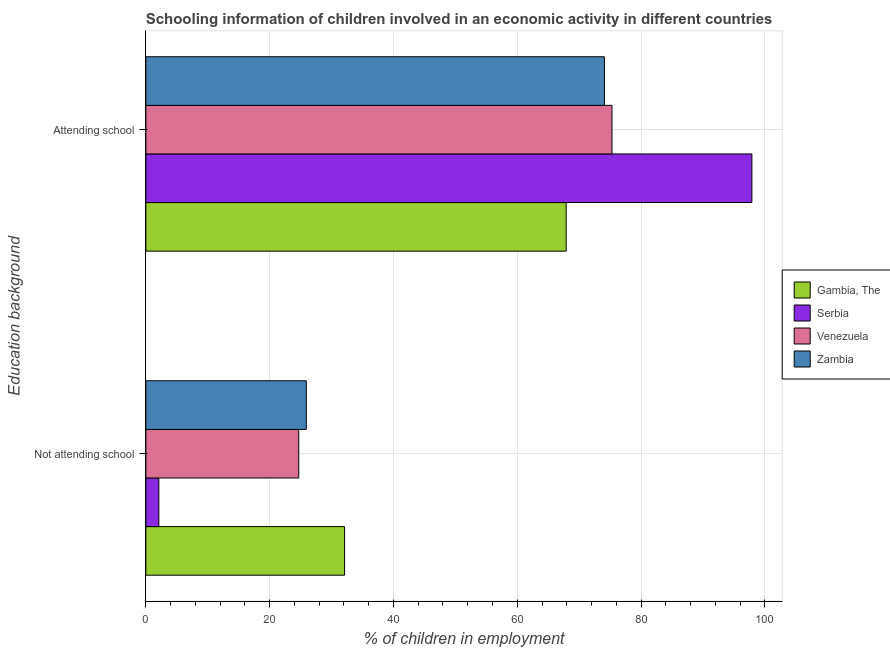How many groups of bars are there?
Keep it short and to the point. 2. How many bars are there on the 2nd tick from the top?
Give a very brief answer. 4. How many bars are there on the 2nd tick from the bottom?
Keep it short and to the point. 4. What is the label of the 1st group of bars from the top?
Your answer should be compact. Attending school. What is the percentage of employed children who are not attending school in Venezuela?
Offer a very short reply. 24.7. Across all countries, what is the maximum percentage of employed children who are not attending school?
Offer a very short reply. 32.1. Across all countries, what is the minimum percentage of employed children who are not attending school?
Provide a short and direct response. 2.1. In which country was the percentage of employed children who are not attending school maximum?
Your answer should be very brief. Gambia, The. In which country was the percentage of employed children who are attending school minimum?
Your response must be concise. Gambia, The. What is the total percentage of employed children who are attending school in the graph?
Offer a terse response. 315.18. What is the difference between the percentage of employed children who are not attending school in Gambia, The and that in Zambia?
Your response must be concise. 6.18. What is the difference between the percentage of employed children who are attending school in Zambia and the percentage of employed children who are not attending school in Gambia, The?
Offer a terse response. 41.98. What is the average percentage of employed children who are attending school per country?
Make the answer very short. 78.79. What is the difference between the percentage of employed children who are attending school and percentage of employed children who are not attending school in Gambia, The?
Ensure brevity in your answer.  35.8. In how many countries, is the percentage of employed children who are attending school greater than 56 %?
Keep it short and to the point. 4. What is the ratio of the percentage of employed children who are attending school in Serbia to that in Zambia?
Make the answer very short. 1.32. Is the percentage of employed children who are not attending school in Venezuela less than that in Serbia?
Provide a succinct answer. No. What does the 1st bar from the top in Not attending school represents?
Your response must be concise. Zambia. What does the 1st bar from the bottom in Attending school represents?
Your response must be concise. Gambia, The. How many bars are there?
Provide a short and direct response. 8. Are all the bars in the graph horizontal?
Your answer should be compact. Yes. What is the difference between two consecutive major ticks on the X-axis?
Offer a very short reply. 20. Are the values on the major ticks of X-axis written in scientific E-notation?
Provide a short and direct response. No. How are the legend labels stacked?
Offer a terse response. Vertical. What is the title of the graph?
Provide a short and direct response. Schooling information of children involved in an economic activity in different countries. What is the label or title of the X-axis?
Keep it short and to the point. % of children in employment. What is the label or title of the Y-axis?
Give a very brief answer. Education background. What is the % of children in employment in Gambia, The in Not attending school?
Offer a terse response. 32.1. What is the % of children in employment of Venezuela in Not attending school?
Your answer should be very brief. 24.7. What is the % of children in employment of Zambia in Not attending school?
Your answer should be very brief. 25.92. What is the % of children in employment of Gambia, The in Attending school?
Make the answer very short. 67.9. What is the % of children in employment in Serbia in Attending school?
Make the answer very short. 97.9. What is the % of children in employment of Venezuela in Attending school?
Make the answer very short. 75.3. What is the % of children in employment in Zambia in Attending school?
Make the answer very short. 74.08. Across all Education background, what is the maximum % of children in employment of Gambia, The?
Keep it short and to the point. 67.9. Across all Education background, what is the maximum % of children in employment in Serbia?
Provide a short and direct response. 97.9. Across all Education background, what is the maximum % of children in employment of Venezuela?
Provide a short and direct response. 75.3. Across all Education background, what is the maximum % of children in employment in Zambia?
Offer a very short reply. 74.08. Across all Education background, what is the minimum % of children in employment in Gambia, The?
Offer a very short reply. 32.1. Across all Education background, what is the minimum % of children in employment in Serbia?
Keep it short and to the point. 2.1. Across all Education background, what is the minimum % of children in employment in Venezuela?
Your response must be concise. 24.7. Across all Education background, what is the minimum % of children in employment in Zambia?
Provide a succinct answer. 25.92. What is the total % of children in employment in Serbia in the graph?
Provide a succinct answer. 100. What is the total % of children in employment in Venezuela in the graph?
Give a very brief answer. 100. What is the difference between the % of children in employment of Gambia, The in Not attending school and that in Attending school?
Make the answer very short. -35.8. What is the difference between the % of children in employment of Serbia in Not attending school and that in Attending school?
Your response must be concise. -95.8. What is the difference between the % of children in employment of Venezuela in Not attending school and that in Attending school?
Keep it short and to the point. -50.6. What is the difference between the % of children in employment of Zambia in Not attending school and that in Attending school?
Offer a terse response. -48.15. What is the difference between the % of children in employment of Gambia, The in Not attending school and the % of children in employment of Serbia in Attending school?
Provide a short and direct response. -65.8. What is the difference between the % of children in employment in Gambia, The in Not attending school and the % of children in employment in Venezuela in Attending school?
Offer a terse response. -43.2. What is the difference between the % of children in employment of Gambia, The in Not attending school and the % of children in employment of Zambia in Attending school?
Offer a very short reply. -41.98. What is the difference between the % of children in employment of Serbia in Not attending school and the % of children in employment of Venezuela in Attending school?
Provide a short and direct response. -73.2. What is the difference between the % of children in employment of Serbia in Not attending school and the % of children in employment of Zambia in Attending school?
Your answer should be very brief. -71.98. What is the difference between the % of children in employment of Venezuela in Not attending school and the % of children in employment of Zambia in Attending school?
Offer a terse response. -49.38. What is the average % of children in employment in Serbia per Education background?
Give a very brief answer. 50. What is the average % of children in employment in Venezuela per Education background?
Offer a very short reply. 50. What is the difference between the % of children in employment in Gambia, The and % of children in employment in Zambia in Not attending school?
Give a very brief answer. 6.18. What is the difference between the % of children in employment in Serbia and % of children in employment in Venezuela in Not attending school?
Ensure brevity in your answer.  -22.6. What is the difference between the % of children in employment of Serbia and % of children in employment of Zambia in Not attending school?
Offer a very short reply. -23.82. What is the difference between the % of children in employment of Venezuela and % of children in employment of Zambia in Not attending school?
Offer a terse response. -1.22. What is the difference between the % of children in employment of Gambia, The and % of children in employment of Venezuela in Attending school?
Make the answer very short. -7.4. What is the difference between the % of children in employment of Gambia, The and % of children in employment of Zambia in Attending school?
Keep it short and to the point. -6.18. What is the difference between the % of children in employment in Serbia and % of children in employment in Venezuela in Attending school?
Give a very brief answer. 22.6. What is the difference between the % of children in employment of Serbia and % of children in employment of Zambia in Attending school?
Ensure brevity in your answer.  23.82. What is the difference between the % of children in employment of Venezuela and % of children in employment of Zambia in Attending school?
Provide a short and direct response. 1.22. What is the ratio of the % of children in employment of Gambia, The in Not attending school to that in Attending school?
Provide a succinct answer. 0.47. What is the ratio of the % of children in employment of Serbia in Not attending school to that in Attending school?
Give a very brief answer. 0.02. What is the ratio of the % of children in employment of Venezuela in Not attending school to that in Attending school?
Provide a short and direct response. 0.33. What is the ratio of the % of children in employment of Zambia in Not attending school to that in Attending school?
Offer a terse response. 0.35. What is the difference between the highest and the second highest % of children in employment of Gambia, The?
Your response must be concise. 35.8. What is the difference between the highest and the second highest % of children in employment of Serbia?
Make the answer very short. 95.8. What is the difference between the highest and the second highest % of children in employment of Venezuela?
Offer a very short reply. 50.6. What is the difference between the highest and the second highest % of children in employment in Zambia?
Give a very brief answer. 48.15. What is the difference between the highest and the lowest % of children in employment of Gambia, The?
Ensure brevity in your answer.  35.8. What is the difference between the highest and the lowest % of children in employment in Serbia?
Make the answer very short. 95.8. What is the difference between the highest and the lowest % of children in employment of Venezuela?
Your answer should be compact. 50.6. What is the difference between the highest and the lowest % of children in employment in Zambia?
Your answer should be compact. 48.15. 